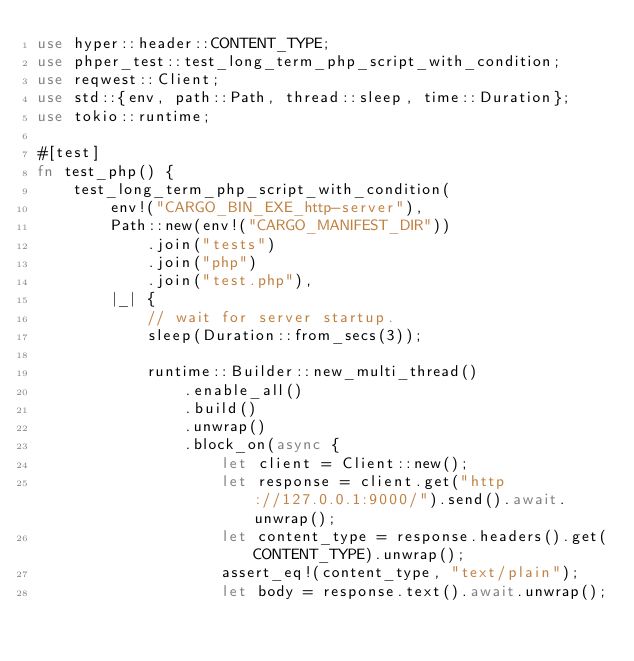<code> <loc_0><loc_0><loc_500><loc_500><_Rust_>use hyper::header::CONTENT_TYPE;
use phper_test::test_long_term_php_script_with_condition;
use reqwest::Client;
use std::{env, path::Path, thread::sleep, time::Duration};
use tokio::runtime;

#[test]
fn test_php() {
    test_long_term_php_script_with_condition(
        env!("CARGO_BIN_EXE_http-server"),
        Path::new(env!("CARGO_MANIFEST_DIR"))
            .join("tests")
            .join("php")
            .join("test.php"),
        |_| {
            // wait for server startup.
            sleep(Duration::from_secs(3));

            runtime::Builder::new_multi_thread()
                .enable_all()
                .build()
                .unwrap()
                .block_on(async {
                    let client = Client::new();
                    let response = client.get("http://127.0.0.1:9000/").send().await.unwrap();
                    let content_type = response.headers().get(CONTENT_TYPE).unwrap();
                    assert_eq!(content_type, "text/plain");
                    let body = response.text().await.unwrap();</code> 